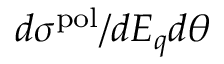<formula> <loc_0><loc_0><loc_500><loc_500>d \sigma ^ { p o l } / d E _ { q } d \theta</formula> 